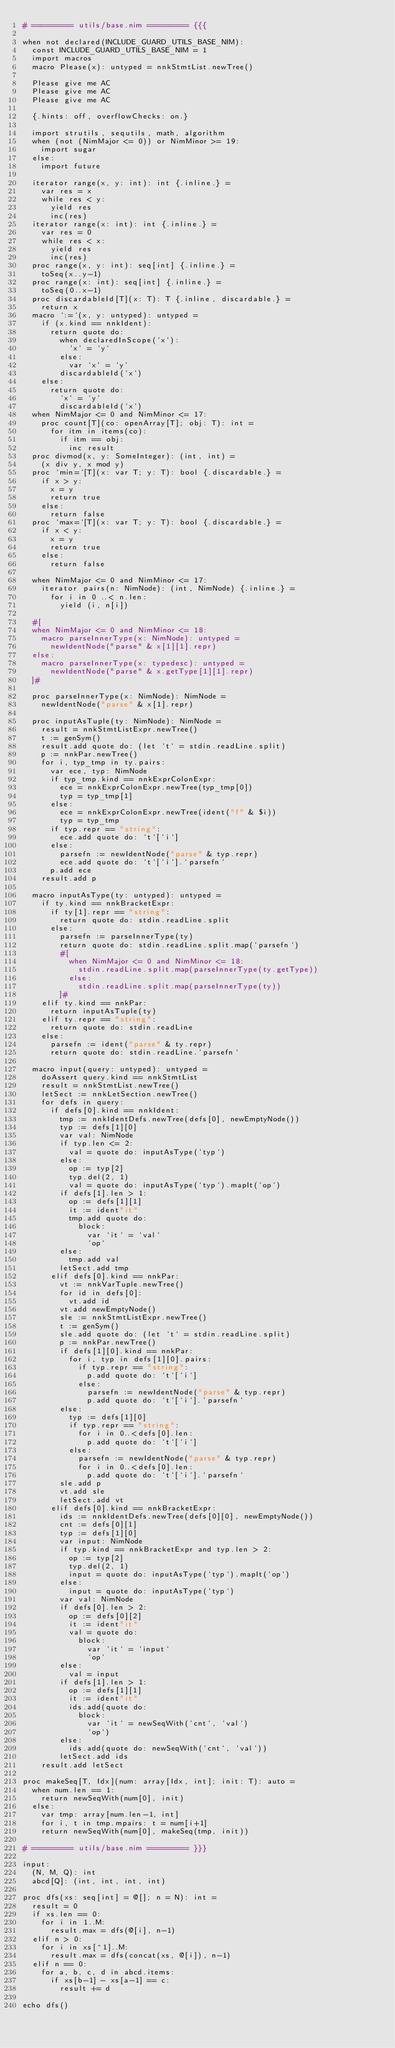<code> <loc_0><loc_0><loc_500><loc_500><_Nim_># ========= utils/base.nim ========= {{{

when not declared(INCLUDE_GUARD_UTILS_BASE_NIM):
  const INCLUDE_GUARD_UTILS_BASE_NIM = 1
  import macros
  macro Please(x): untyped = nnkStmtList.newTree()

  Please give me AC
  Please give me AC
  Please give me AC

  {.hints: off, overflowChecks: on.}

  import strutils, sequtils, math, algorithm
  when (not (NimMajor <= 0)) or NimMinor >= 19:
    import sugar
  else:
    import future

  iterator range(x, y: int): int {.inline.} =
    var res = x
    while res < y:
      yield res
      inc(res)
  iterator range(x: int): int {.inline.} =
    var res = 0
    while res < x:
      yield res
      inc(res)
  proc range(x, y: int): seq[int] {.inline.} =
    toSeq(x..y-1)
  proc range(x: int): seq[int] {.inline.} =
    toSeq(0..x-1)
  proc discardableId[T](x: T): T {.inline, discardable.} =
    return x
  macro `:=`(x, y: untyped): untyped =
    if (x.kind == nnkIdent):
      return quote do:
        when declaredInScope(`x`):
          `x` = `y`
        else:
          var `x` = `y`
        discardableId(`x`)
    else:
      return quote do:
        `x` = `y`
        discardableId(`x`)
  when NimMajor <= 0 and NimMinor <= 17:
    proc count[T](co: openArray[T]; obj: T): int =
      for itm in items(co):
        if itm == obj:
          inc result
  proc divmod(x, y: SomeInteger): (int, int) =
    (x div y, x mod y)
  proc `min=`[T](x: var T; y: T): bool {.discardable.} =
    if x > y:
      x = y
      return true
    else:
      return false
  proc `max=`[T](x: var T; y: T): bool {.discardable.} =
    if x < y:
      x = y
      return true
    else:
      return false

  when NimMajor <= 0 and NimMinor <= 17:
    iterator pairs(n: NimNode): (int, NimNode) {.inline.} =
      for i in 0 ..< n.len:
        yield (i, n[i])

  #[
  when NimMajor <= 0 and NimMinor <= 18:
    macro parseInnerType(x: NimNode): untyped =
      newIdentNode("parse" & x[1][1].repr)
  else:
    macro parseInnerType(x: typedesc): untyped =
      newIdentNode("parse" & x.getType[1][1].repr)
  ]#

  proc parseInnerType(x: NimNode): NimNode =
    newIdentNode("parse" & x[1].repr)

  proc inputAsTuple(ty: NimNode): NimNode =
    result = nnkStmtListExpr.newTree()
    t := genSym()
    result.add quote do: (let `t` = stdin.readLine.split)
    p := nnkPar.newTree()
    for i, typ_tmp in ty.pairs:
      var ece, typ: NimNode
      if typ_tmp.kind == nnkExprColonExpr:
        ece = nnkExprColonExpr.newTree(typ_tmp[0])
        typ = typ_tmp[1]
      else:
        ece = nnkExprColonExpr.newTree(ident("f" & $i))
        typ = typ_tmp
      if typ.repr == "string":
        ece.add quote do: `t`[`i`]
      else:
        parsefn := newIdentNode("parse" & typ.repr)
        ece.add quote do: `t`[`i`].`parsefn`
      p.add ece
    result.add p

  macro inputAsType(ty: untyped): untyped =
    if ty.kind == nnkBracketExpr:
      if ty[1].repr == "string":
        return quote do: stdin.readLine.split
      else:
        parsefn := parseInnerType(ty)
        return quote do: stdin.readLine.split.map(`parsefn`)
        #[
          when NimMajor <= 0 and NimMinor <= 18:
            stdin.readLine.split.map(parseInnerType(ty.getType))
          else:
            stdin.readLine.split.map(parseInnerType(ty))
        ]#
    elif ty.kind == nnkPar:
      return inputAsTuple(ty)
    elif ty.repr == "string":
      return quote do: stdin.readLine
    else:
      parsefn := ident("parse" & ty.repr)
      return quote do: stdin.readLine.`parsefn`

  macro input(query: untyped): untyped =
    doAssert query.kind == nnkStmtList
    result = nnkStmtList.newTree()
    letSect := nnkLetSection.newTree()
    for defs in query:
      if defs[0].kind == nnkIdent:
        tmp := nnkIdentDefs.newTree(defs[0], newEmptyNode())
        typ := defs[1][0]
        var val: NimNode
        if typ.len <= 2:
          val = quote do: inputAsType(`typ`)
        else:
          op := typ[2]
          typ.del(2, 1)
          val = quote do: inputAsType(`typ`).mapIt(`op`)
        if defs[1].len > 1:
          op := defs[1][1]
          it := ident"it"
          tmp.add quote do:
            block:
              var `it` = `val`
              `op`
        else:
          tmp.add val
        letSect.add tmp
      elif defs[0].kind == nnkPar:
        vt := nnkVarTuple.newTree()
        for id in defs[0]:
          vt.add id
        vt.add newEmptyNode()
        sle := nnkStmtListExpr.newTree()
        t := genSym()
        sle.add quote do: (let `t` = stdin.readLine.split)
        p := nnkPar.newTree()
        if defs[1][0].kind == nnkPar:
          for i, typ in defs[1][0].pairs:
            if typ.repr == "string":
              p.add quote do: `t`[`i`]
            else:
              parsefn := newIdentNode("parse" & typ.repr)
              p.add quote do: `t`[`i`].`parsefn`
        else:
          typ := defs[1][0]
          if typ.repr == "string":
            for i in 0..<defs[0].len:
              p.add quote do: `t`[`i`]
          else:
            parsefn := newIdentNode("parse" & typ.repr)
            for i in 0..<defs[0].len:
              p.add quote do: `t`[`i`].`parsefn`
        sle.add p
        vt.add sle
        letSect.add vt
      elif defs[0].kind == nnkBracketExpr:
        ids := nnkIdentDefs.newTree(defs[0][0], newEmptyNode())
        cnt := defs[0][1]
        typ := defs[1][0]
        var input: NimNode
        if typ.kind == nnkBracketExpr and typ.len > 2:
          op := typ[2]
          typ.del(2, 1)
          input = quote do: inputAsType(`typ`).mapIt(`op`)
        else:
          input = quote do: inputAsType(`typ`)
        var val: NimNode
        if defs[0].len > 2:
          op := defs[0][2]
          it := ident"it"
          val = quote do:
            block:
              var `it` = `input`
              `op`
        else:
          val = input
        if defs[1].len > 1:
          op := defs[1][1]
          it := ident"it"
          ids.add(quote do:
            block:
              var `it` = newSeqWith(`cnt`, `val`)
              `op`)
        else:
          ids.add(quote do: newSeqWith(`cnt`, `val`))
        letSect.add ids
    result.add letSect

proc makeSeq[T, Idx](num: array[Idx, int]; init: T): auto =
  when num.len == 1:
    return newSeqWith(num[0], init)
  else:
    var tmp: array[num.len-1, int]
    for i, t in tmp.mpairs: t = num[i+1]
    return newSeqWith(num[0], makeSeq(tmp, init))

# ========= utils/base.nim ========= }}}

input:
  (N, M, Q): int
  abcd[Q]: (int, int, int, int)

proc dfs(xs: seq[int] = @[]; n = N): int =
  result = 0
  if xs.len == 0:
    for i in 1..M:
      result.max = dfs(@[i], n-1)
  elif n > 0:
    for i in xs[^1]..M:
      result.max = dfs(concat(xs, @[i]), n-1)
  elif n == 0:
    for a, b, c, d in abcd.items:
      if xs[b-1] - xs[a-1] == c:
        result += d

echo dfs()
</code> 